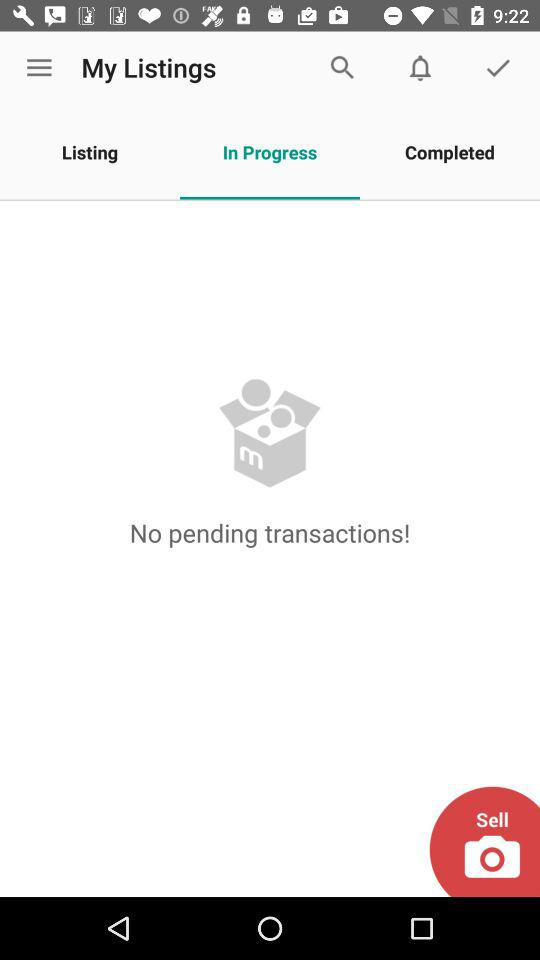Are there any pending transactions? There are no pending transactions. 